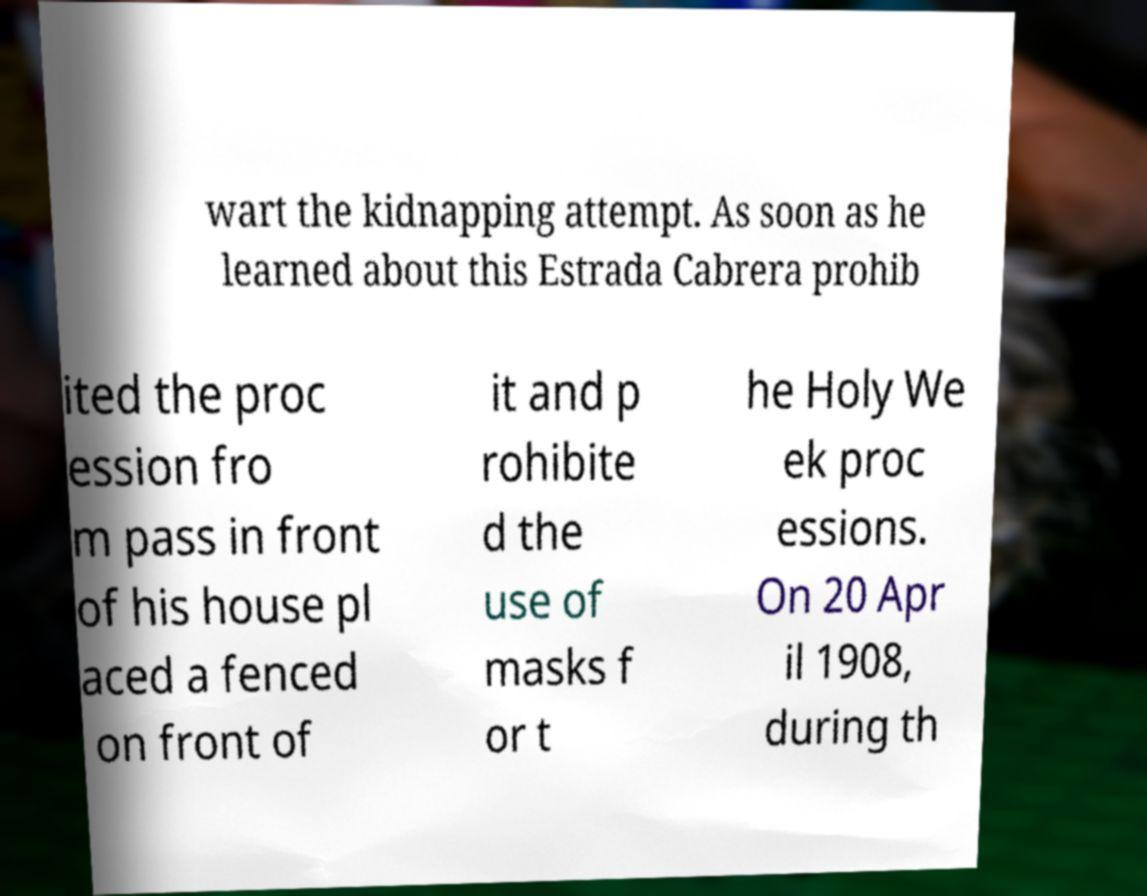Please identify and transcribe the text found in this image. wart the kidnapping attempt. As soon as he learned about this Estrada Cabrera prohib ited the proc ession fro m pass in front of his house pl aced a fenced on front of it and p rohibite d the use of masks f or t he Holy We ek proc essions. On 20 Apr il 1908, during th 